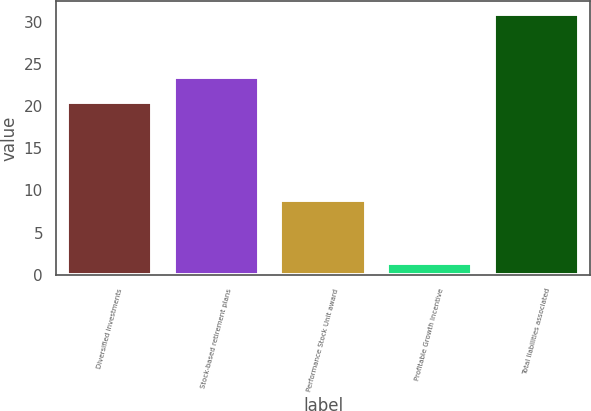<chart> <loc_0><loc_0><loc_500><loc_500><bar_chart><fcel>Diversified investments<fcel>Stock-based retirement plans<fcel>Performance Stock Unit award<fcel>Profitable Growth Incentive<fcel>Total liabilities associated<nl><fcel>20.5<fcel>23.45<fcel>8.8<fcel>1.4<fcel>30.9<nl></chart> 